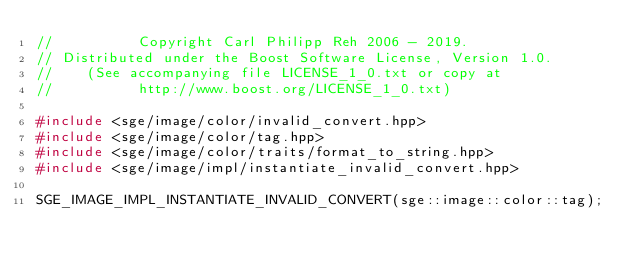<code> <loc_0><loc_0><loc_500><loc_500><_C++_>//          Copyright Carl Philipp Reh 2006 - 2019.
// Distributed under the Boost Software License, Version 1.0.
//    (See accompanying file LICENSE_1_0.txt or copy at
//          http://www.boost.org/LICENSE_1_0.txt)

#include <sge/image/color/invalid_convert.hpp>
#include <sge/image/color/tag.hpp>
#include <sge/image/color/traits/format_to_string.hpp>
#include <sge/image/impl/instantiate_invalid_convert.hpp>

SGE_IMAGE_IMPL_INSTANTIATE_INVALID_CONVERT(sge::image::color::tag);
</code> 